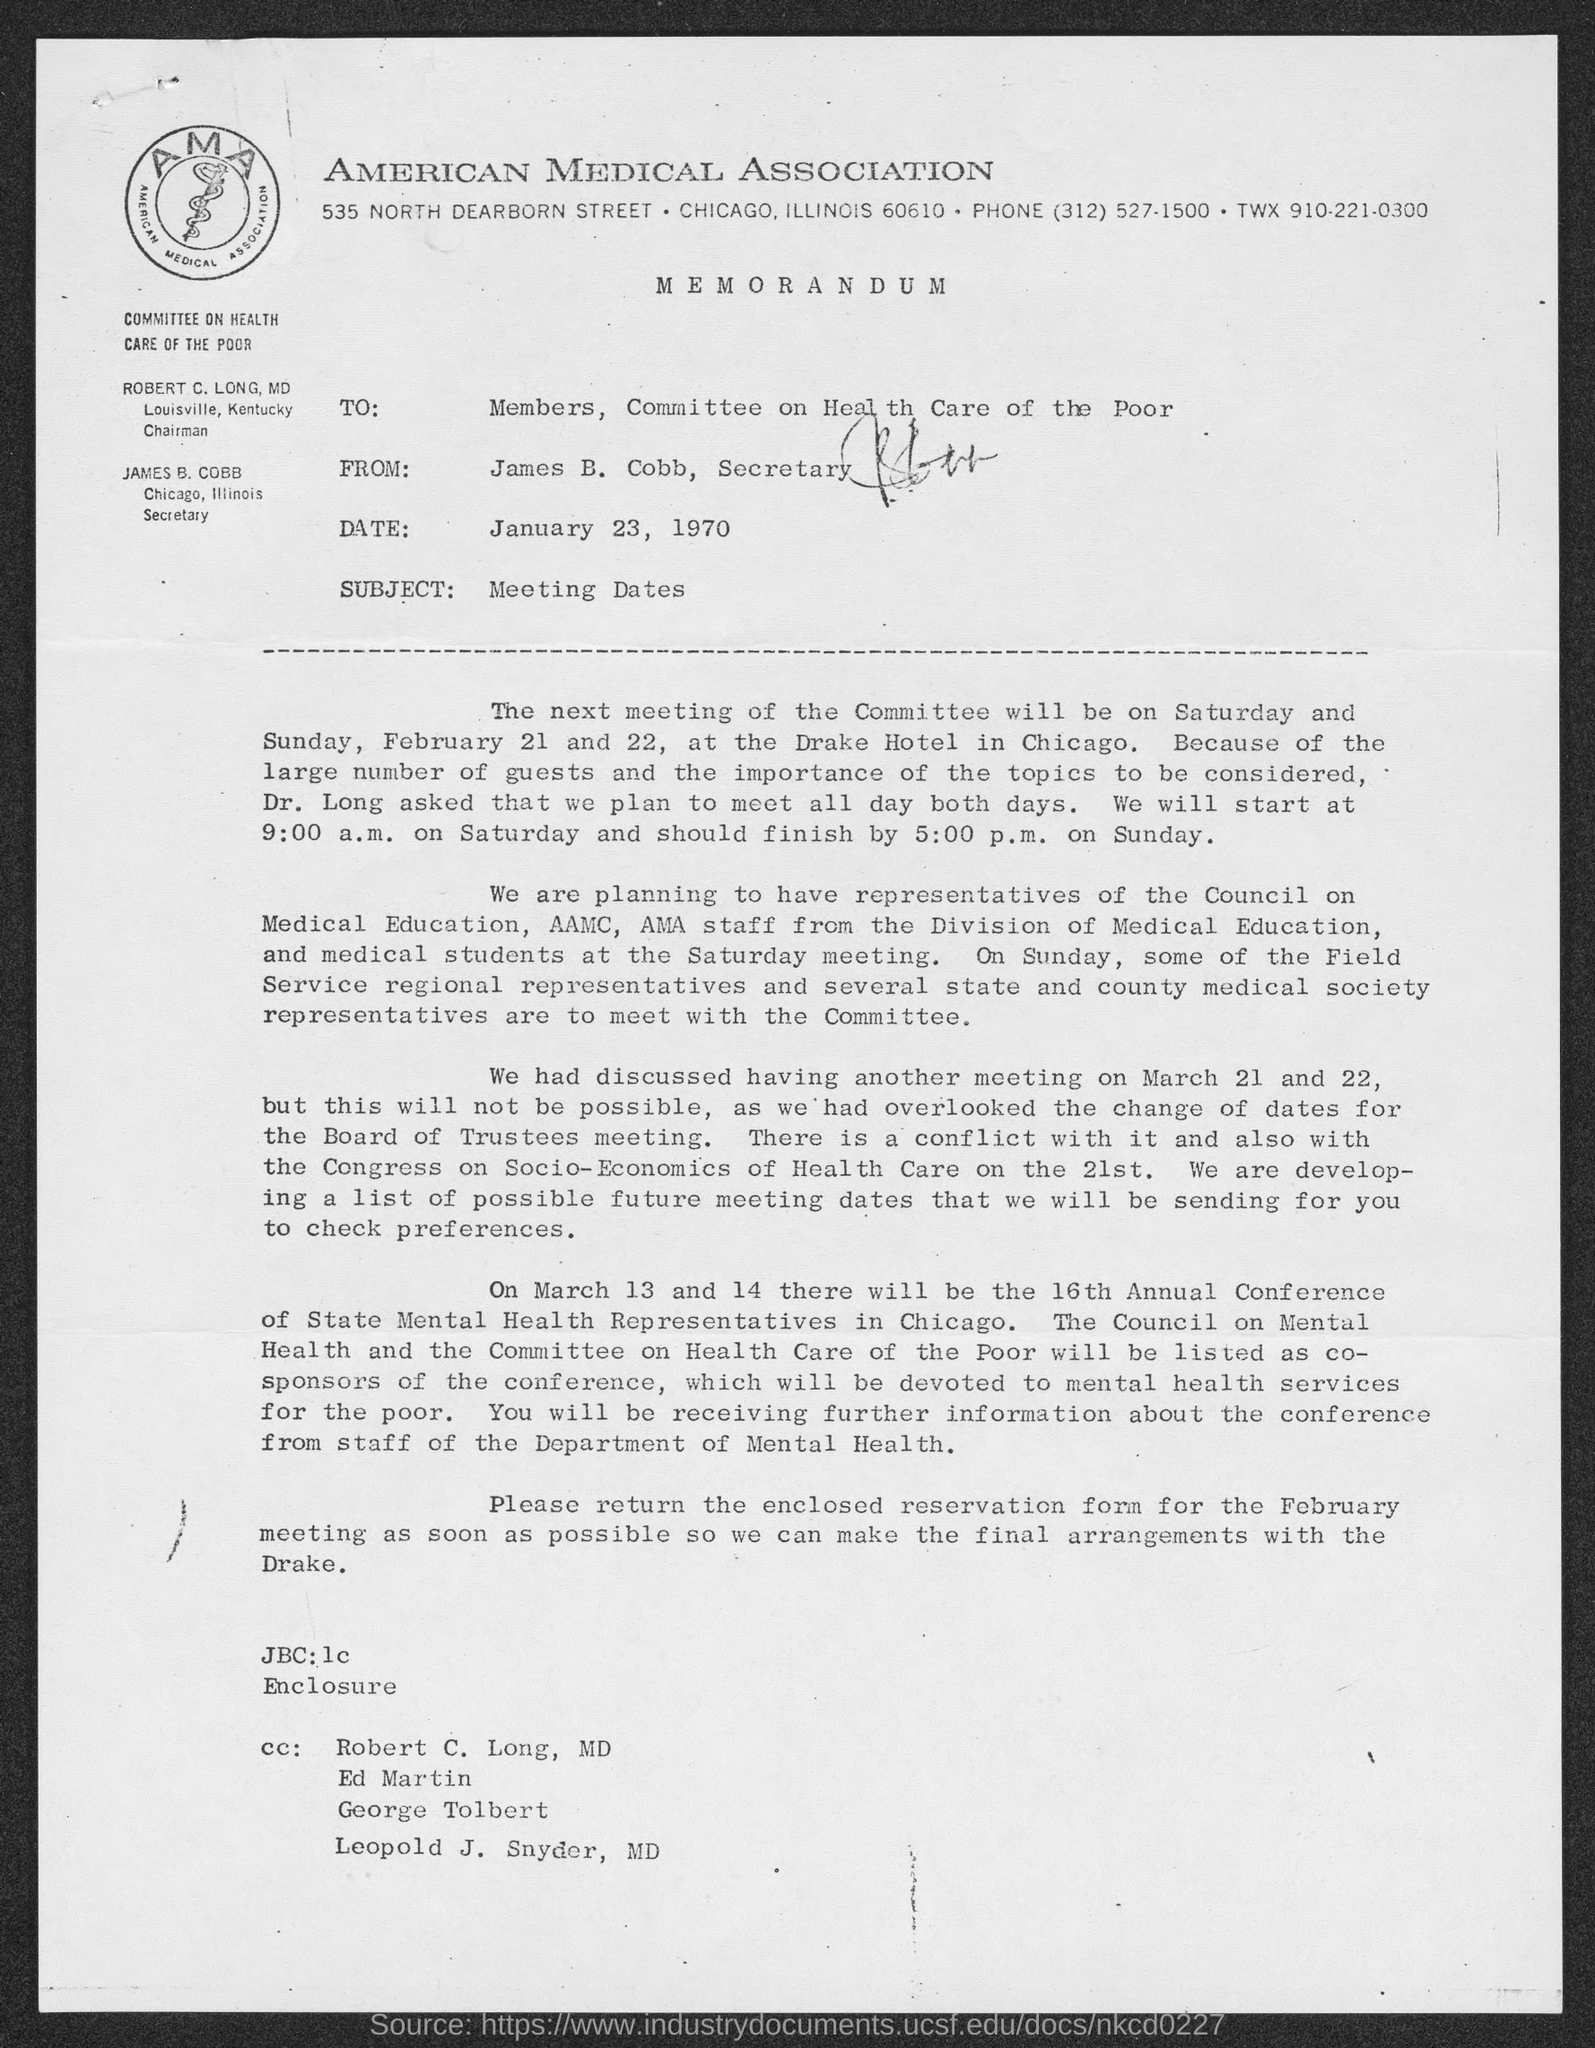Point out several critical features in this image. The memorandum's from address is James B. Cobb. The subject of the memorandum is the dates of the upcoming meetings. The American Medical Association is located in Chicago. James B. Cobb holds the position of Secretary. The memorandum is dated January 23, 1970. 